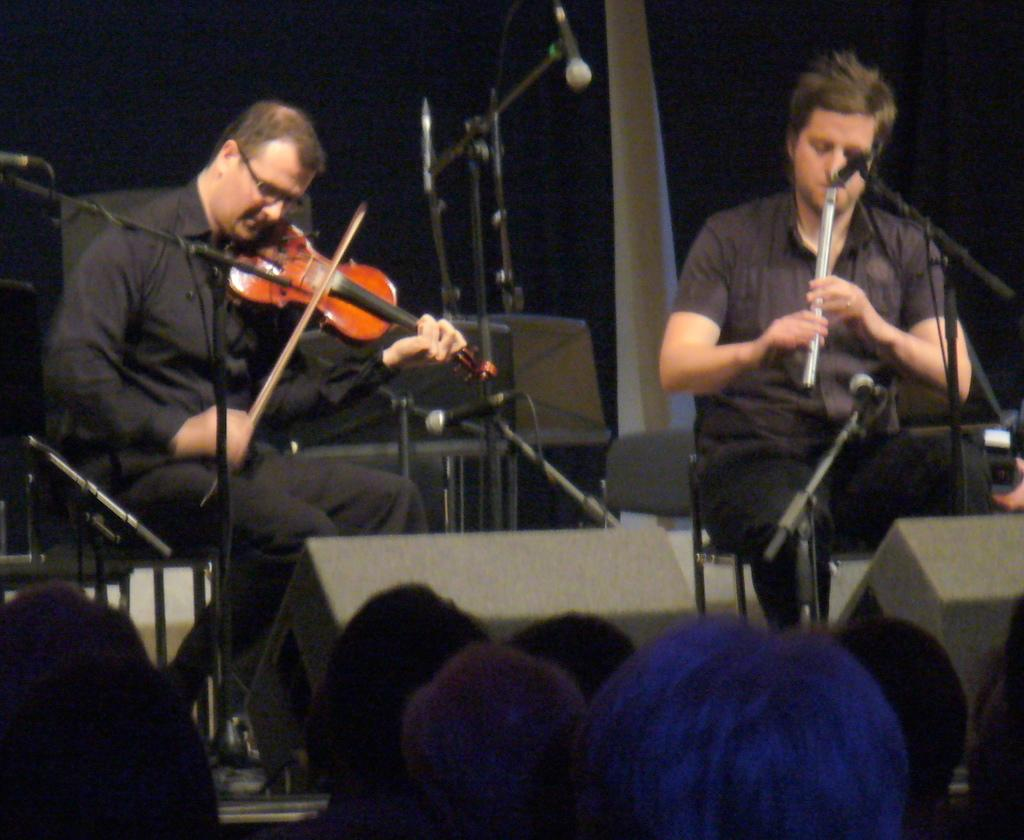How many people are in the image? There are two men in the image. What are the men doing in the image? The men are sitting on chairs. What objects related to music can be seen in the image? There are musical instruments and a microphone in the image. How does the audience in the image appear to be reacting to the performance? The audience appears to be enjoying the show. What type of drug is being used by the men in the image? There is no indication of any drug use in the image; the men are playing musical instruments. What rule is being broken by the men in the image? There is no indication of any rule being broken in the image; the men are playing music for an audience. 